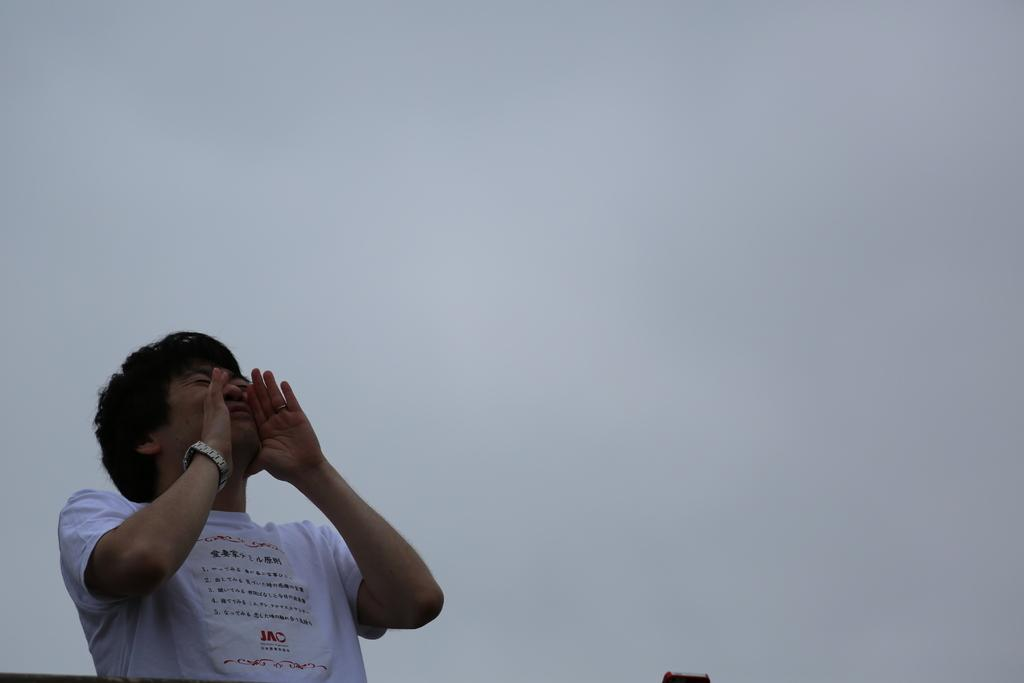What is the main subject of the image? There is a person in the image. What can be seen in the background of the image? The sky is visible behind the person. How many quince are being washed by the person in the image? There are no quince or washing activity present in the image. 